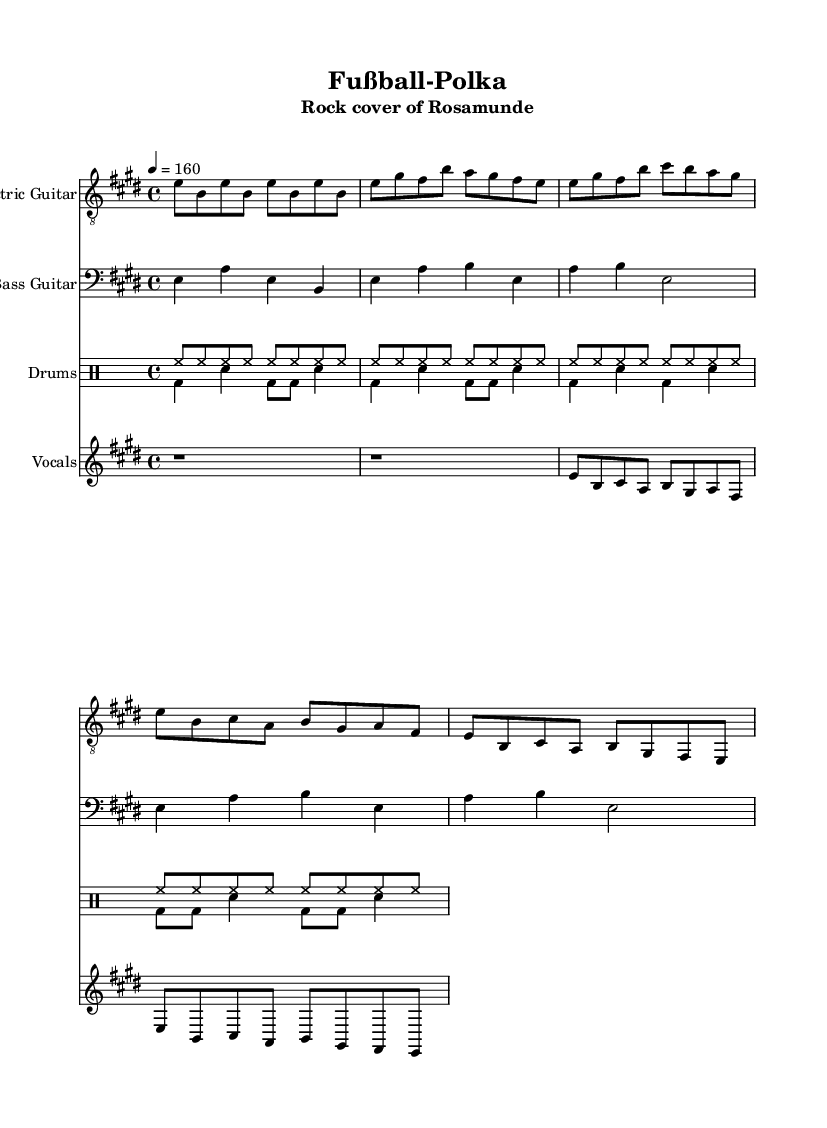What is the key signature of this music? The key signature is indicated by the sharp sign shown at the beginning of the music, which is E major. E major has four sharps (F#, C#, G#, D#).
Answer: E major What is the time signature for this piece? The time signature is located at the beginning of the music, specified as 4/4, allowing four beats per measure.
Answer: 4/4 What is the tempo marking of the piece? The tempo marking is indicated by "4 = 160," which means there are 160 beats per minute.
Answer: 160 How many bars are in the chorus section? By counting the measures in the chorus segment, it consists of two phrases with four measures each, totaling eight measures.
Answer: 8 What type of drum pattern is used throughout the piece? The drums feature a basic rock beat with alternating hi-hat and bass drum patterns, common in rock music.
Answer: Rock beat What instrument plays the main melody? The main melody is assigned to the vocals in the piece, signified by the staff labeled "Vocals."
Answer: Vocals What is the title of this piece? The title appears prominently at the top of the music sheet as "Fußball-Polka."
Answer: Fußball-Polka 